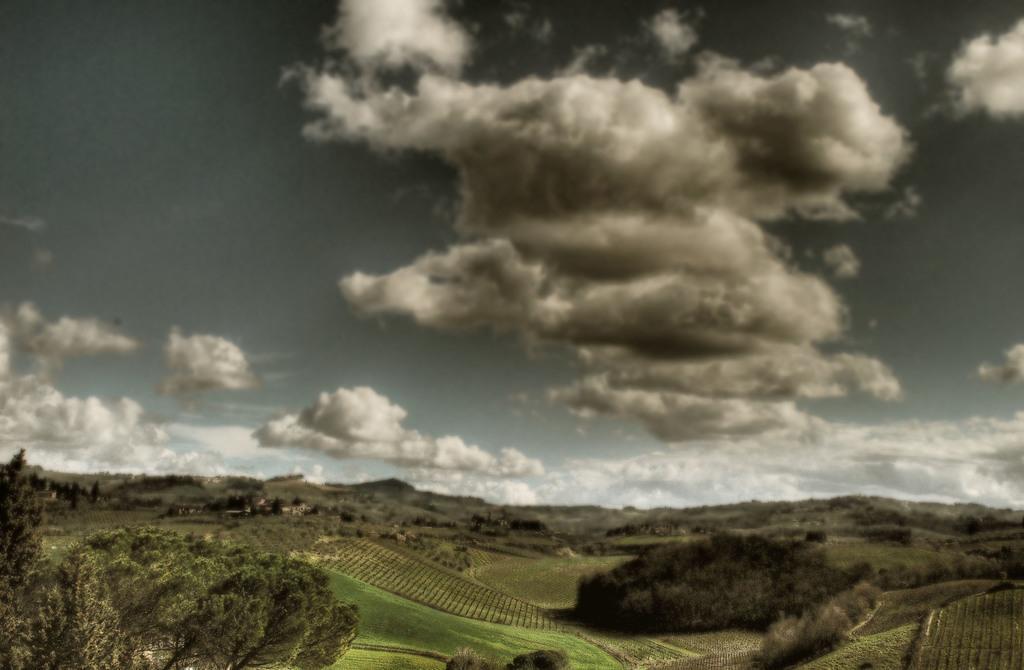Could you give a brief overview of what you see in this image? At the bottom of the picture, we see the grass and the trees. There are trees in the background. At the top of the picture, we see the sky and the clouds. 